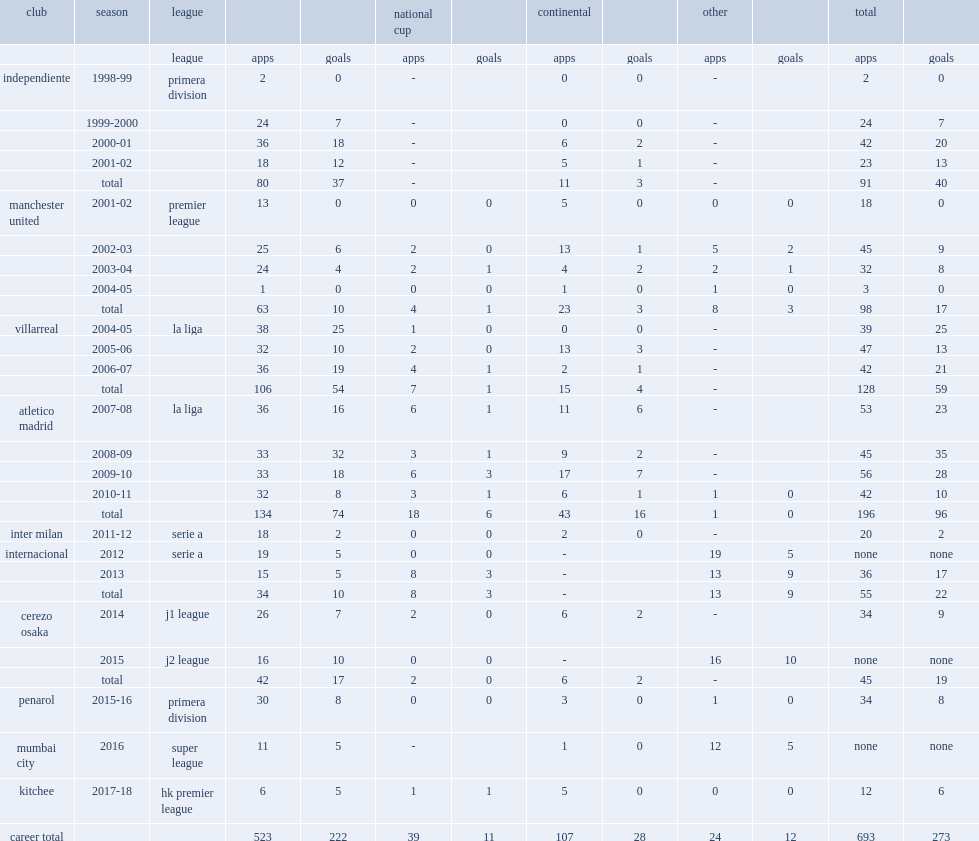Could you help me parse every detail presented in this table? {'header': ['club', 'season', 'league', '', '', 'national cup', '', 'continental', '', 'other', '', 'total', ''], 'rows': [['', '', 'league', 'apps', 'goals', 'apps', 'goals', 'apps', 'goals', 'apps', 'goals', 'apps', 'goals'], ['independiente', '1998-99', 'primera division', '2', '0', '-', '', '0', '0', '-', '', '2', '0'], ['', '1999-2000', '', '24', '7', '-', '', '0', '0', '-', '', '24', '7'], ['', '2000-01', '', '36', '18', '-', '', '6', '2', '-', '', '42', '20'], ['', '2001-02', '', '18', '12', '-', '', '5', '1', '-', '', '23', '13'], ['', 'total', '', '80', '37', '-', '', '11', '3', '-', '', '91', '40'], ['manchester united', '2001-02', 'premier league', '13', '0', '0', '0', '5', '0', '0', '0', '18', '0'], ['', '2002-03', '', '25', '6', '2', '0', '13', '1', '5', '2', '45', '9'], ['', '2003-04', '', '24', '4', '2', '1', '4', '2', '2', '1', '32', '8'], ['', '2004-05', '', '1', '0', '0', '0', '1', '0', '1', '0', '3', '0'], ['', 'total', '', '63', '10', '4', '1', '23', '3', '8', '3', '98', '17'], ['villarreal', '2004-05', 'la liga', '38', '25', '1', '0', '0', '0', '-', '', '39', '25'], ['', '2005-06', '', '32', '10', '2', '0', '13', '3', '-', '', '47', '13'], ['', '2006-07', '', '36', '19', '4', '1', '2', '1', '-', '', '42', '21'], ['', 'total', '', '106', '54', '7', '1', '15', '4', '-', '', '128', '59'], ['atletico madrid', '2007-08', 'la liga', '36', '16', '6', '1', '11', '6', '-', '', '53', '23'], ['', '2008-09', '', '33', '32', '3', '1', '9', '2', '-', '', '45', '35'], ['', '2009-10', '', '33', '18', '6', '3', '17', '7', '-', '', '56', '28'], ['', '2010-11', '', '32', '8', '3', '1', '6', '1', '1', '0', '42', '10'], ['', 'total', '', '134', '74', '18', '6', '43', '16', '1', '0', '196', '96'], ['inter milan', '2011-12', 'serie a', '18', '2', '0', '0', '2', '0', '-', '', '20', '2'], ['internacional', '2012', 'serie a', '19', '5', '0', '0', '-', '', '19', '5', 'none', 'none'], ['', '2013', '', '15', '5', '8', '3', '-', '', '13', '9', '36', '17'], ['', 'total', '', '34', '10', '8', '3', '-', '', '13', '9', '55', '22'], ['cerezo osaka', '2014', 'j1 league', '26', '7', '2', '0', '6', '2', '-', '', '34', '9'], ['', '2015', 'j2 league', '16', '10', '0', '0', '-', '', '16', '10', 'none', 'none'], ['', 'total', '', '42', '17', '2', '0', '6', '2', '-', '', '45', '19'], ['penarol', '2015-16', 'primera division', '30', '8', '0', '0', '3', '0', '1', '0', '34', '8'], ['mumbai city', '2016', 'super league', '11', '5', '-', '', '1', '0', '12', '5', 'none', 'none'], ['kitchee', '2017-18', 'hk premier league', '6', '5', '1', '1', '5', '0', '0', '0', '12', '6'], ['career total', '', '', '523', '222', '39', '11', '107', '28', '24', '12', '693', '273']]} How many goals did forlan score in the premier league for manchester united? 6.0. 